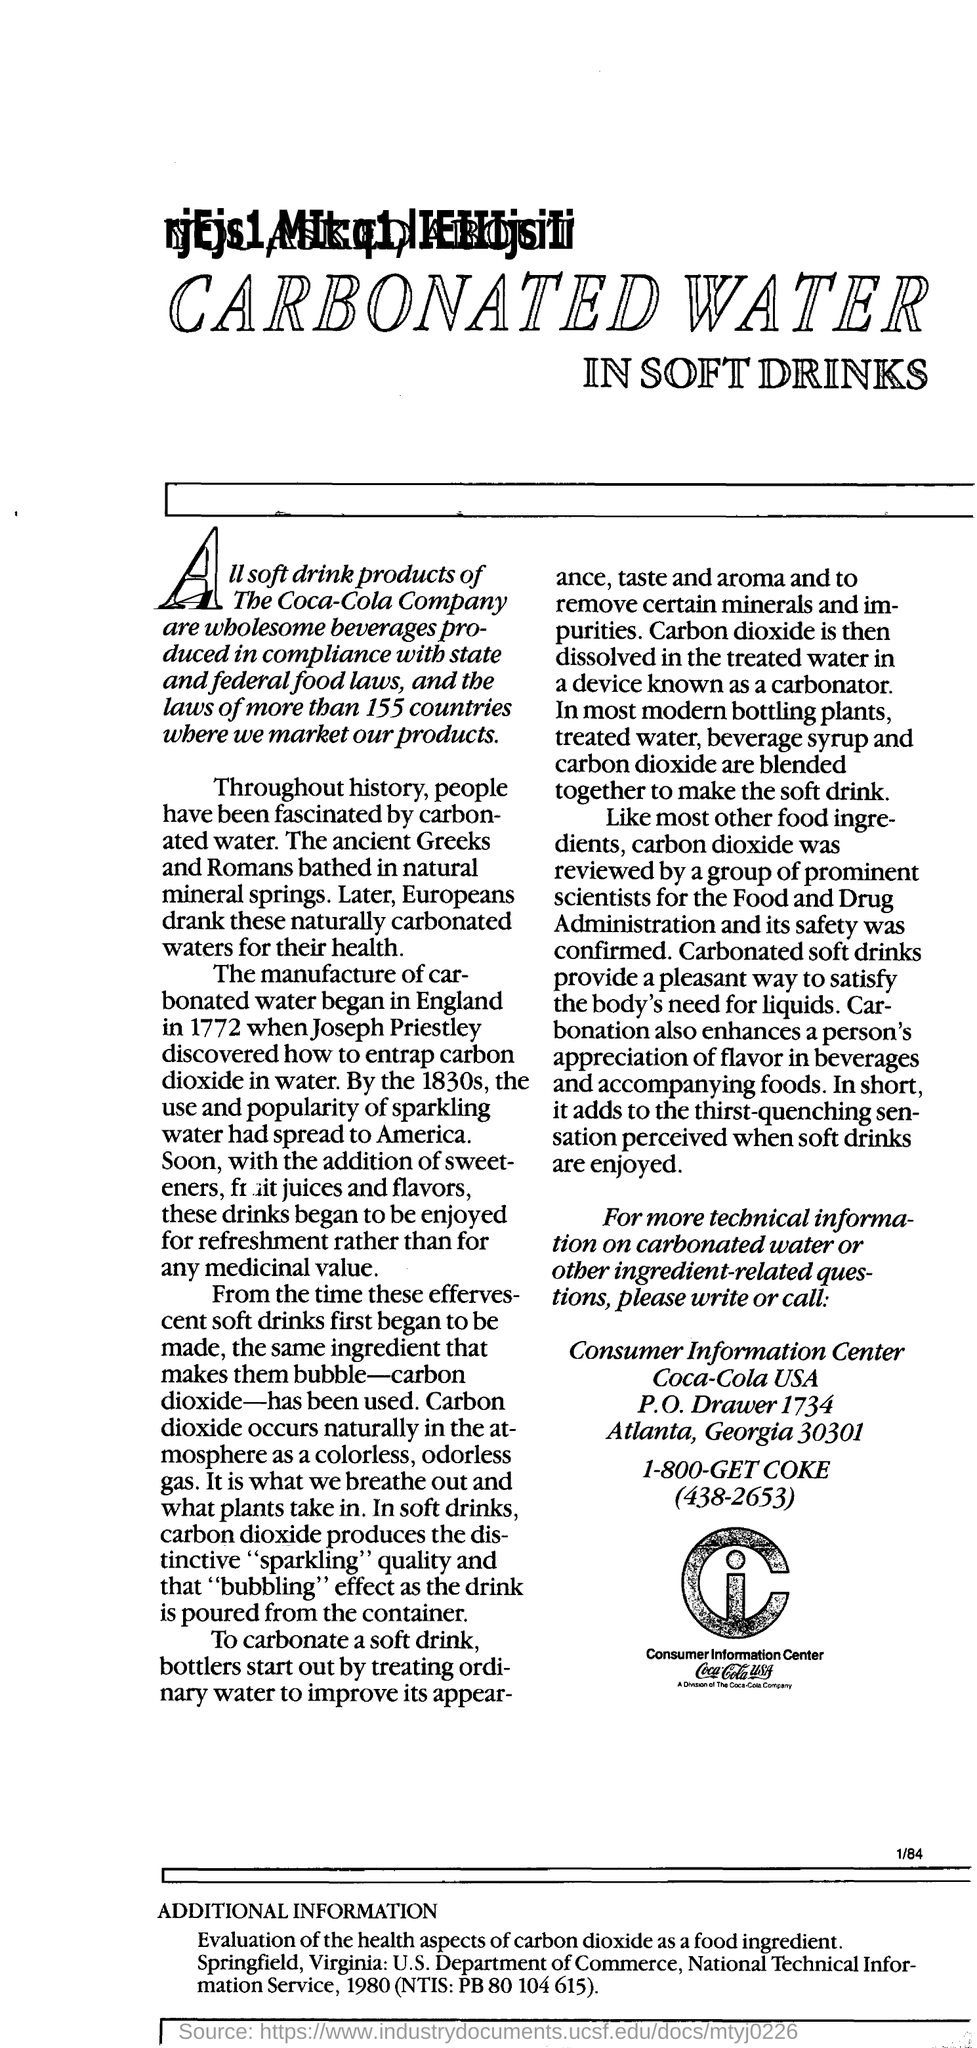List a handful of essential elements in this visual. A group of esteemed scientists, appointed by the Food and Drug Administration, have reviewed and assessed the safety of carbon dioxide in food. Carbon dioxide is responsible for producing the distinctive "sparkling" quality and bubbling effect in soft drinks as it is poured from the container. The given information pertains to the Consumer Information Center of Coca-Cola USA. Coca-Cola products are marketed in more than 155 countries worldwide. The manufacture of carbonated water began in 1772. 